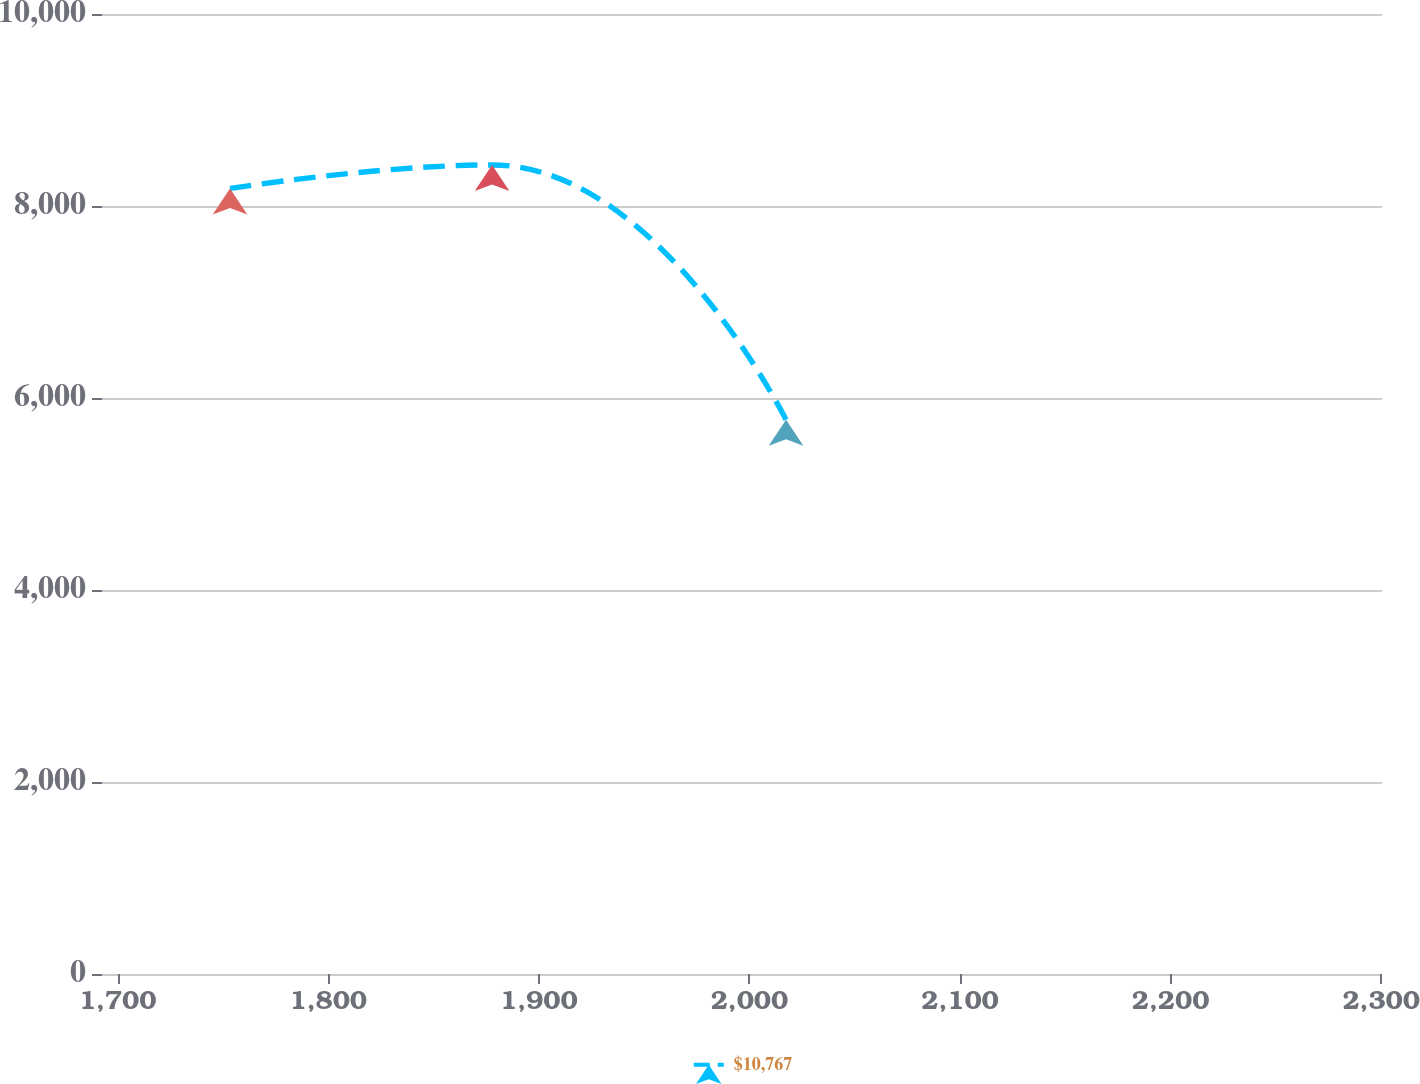<chart> <loc_0><loc_0><loc_500><loc_500><line_chart><ecel><fcel>$10,767<nl><fcel>1753.36<fcel>8183.19<nl><fcel>1877.81<fcel>8427.83<nl><fcel>2017.4<fcel>5773.33<nl><fcel>2361.17<fcel>6124.82<nl></chart> 